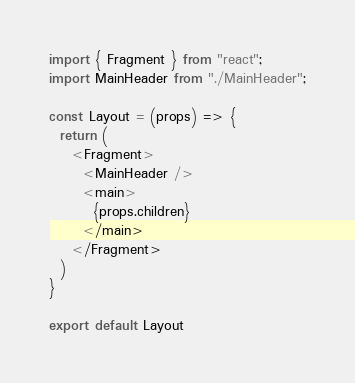Convert code to text. <code><loc_0><loc_0><loc_500><loc_500><_JavaScript_>import { Fragment } from "react";
import MainHeader from "./MainHeader";

const Layout = (props) => {
  return (
    <Fragment>
      <MainHeader />
      <main>
        {props.children}
      </main>
    </Fragment>
  )
}

export default Layout
</code> 